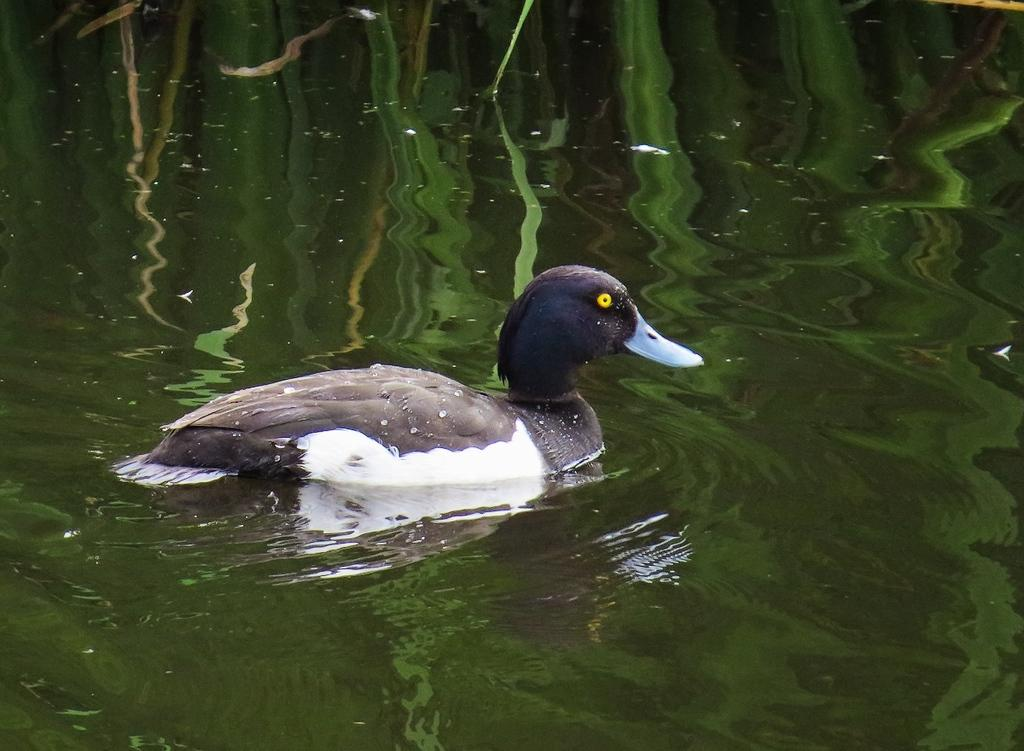What is the primary element visible in the image? There is water in the image. Can you describe any animals present in the water? There is a black and white duck in the water. What type of bed can be seen in the image? There is no bed present in the image; it features water and a black and white duck. How does the duck transport itself in the image? The duck is swimming in the water, which is its natural mode of transportation. 